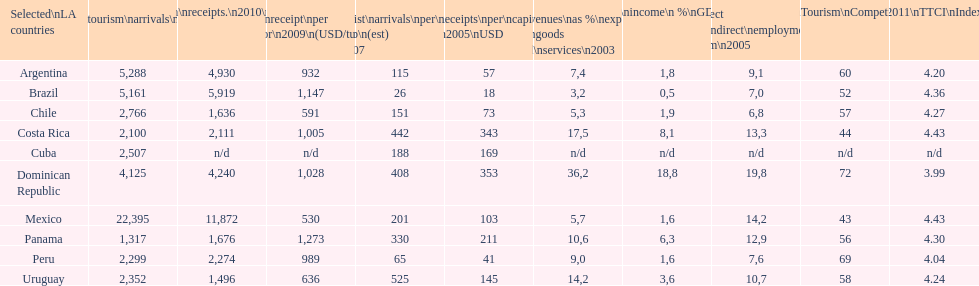What country had the least arrivals per 1000 inhabitants in 2007(estimated)? Brazil. 